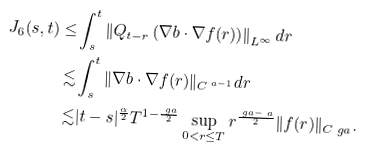<formula> <loc_0><loc_0><loc_500><loc_500>J _ { 6 } ( s , t ) \leq & \int _ { s } ^ { t } \left \| Q _ { t - r } \left ( \nabla b \cdot \nabla f ( r ) \right ) \right \| _ { L ^ { \infty } } d r \\ \lesssim & \int _ { s } ^ { t } \| \nabla b \cdot \nabla f ( r ) \| _ { C ^ { \ a - 1 } } d r \\ \lesssim & | t - s | ^ { \frac { \alpha } 2 } T ^ { 1 - \frac { \ g a } { 2 } } \sup _ { 0 < r \leq T } r ^ { \frac { \ g a - \ a } 2 } \| f ( r ) \| _ { C ^ { \ } g a } .</formula> 